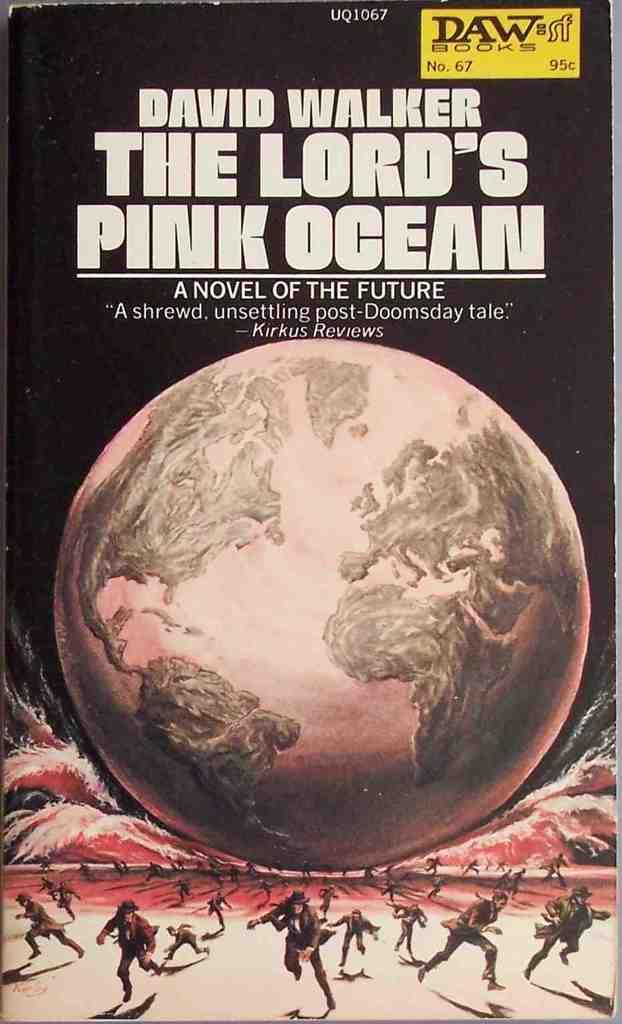<image>
Relay a brief, clear account of the picture shown. A cover of a novel by David Walker shows the earth and people running away from it. 